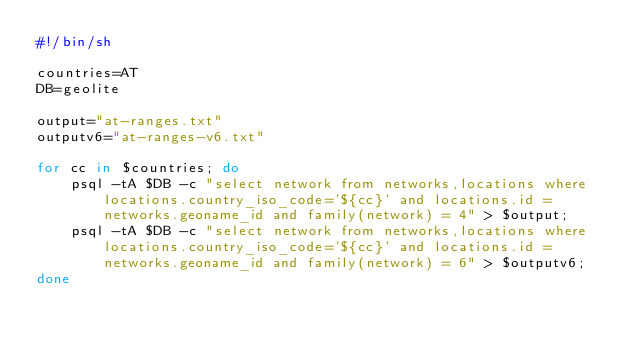Convert code to text. <code><loc_0><loc_0><loc_500><loc_500><_Bash_>#!/bin/sh

countries=AT
DB=geolite

output="at-ranges.txt"
outputv6="at-ranges-v6.txt"

for cc in $countries; do
    psql -tA $DB -c "select network from networks,locations where locations.country_iso_code='${cc}' and locations.id = networks.geoname_id and family(network) = 4" > $output;
    psql -tA $DB -c "select network from networks,locations where locations.country_iso_code='${cc}' and locations.id = networks.geoname_id and family(network) = 6" > $outputv6;
done
</code> 